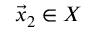Convert formula to latex. <formula><loc_0><loc_0><loc_500><loc_500>{ \vec { x } } _ { 2 } \in X</formula> 